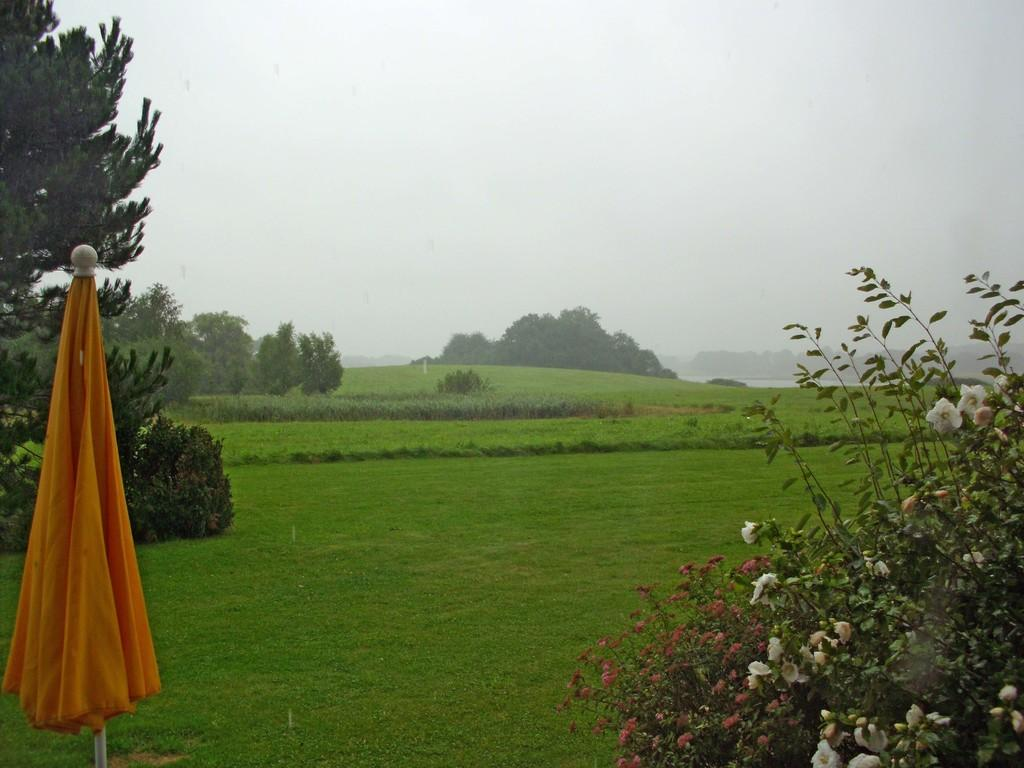What object is located on the left side of the image? There is an umbrella on the left side of the image. What can be seen on the right side of the image? There are flowers on the right side of the image. What type of vegetation is visible in the background of the image? There is grass in the background of the image. What else can be seen in the background of the image? There are trees in the background of the image. Can you tell me how many sisters are depicted in the image? There are no sisters present in the image; it features an umbrella, flowers, grass, and trees. What type of badge is visible on the umbrella in the image? There is no badge present on the umbrella in the image. 